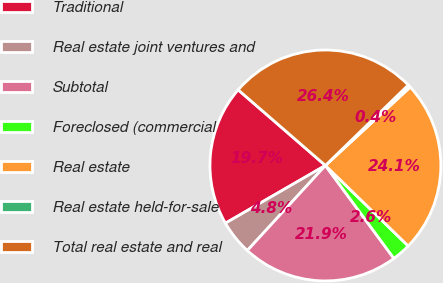Convert chart to OTSL. <chart><loc_0><loc_0><loc_500><loc_500><pie_chart><fcel>Traditional<fcel>Real estate joint ventures and<fcel>Subtotal<fcel>Foreclosed (commercial<fcel>Real estate<fcel>Real estate held-for-sale<fcel>Total real estate and real<nl><fcel>19.7%<fcel>4.85%<fcel>21.92%<fcel>2.62%<fcel>24.15%<fcel>0.39%<fcel>26.37%<nl></chart> 